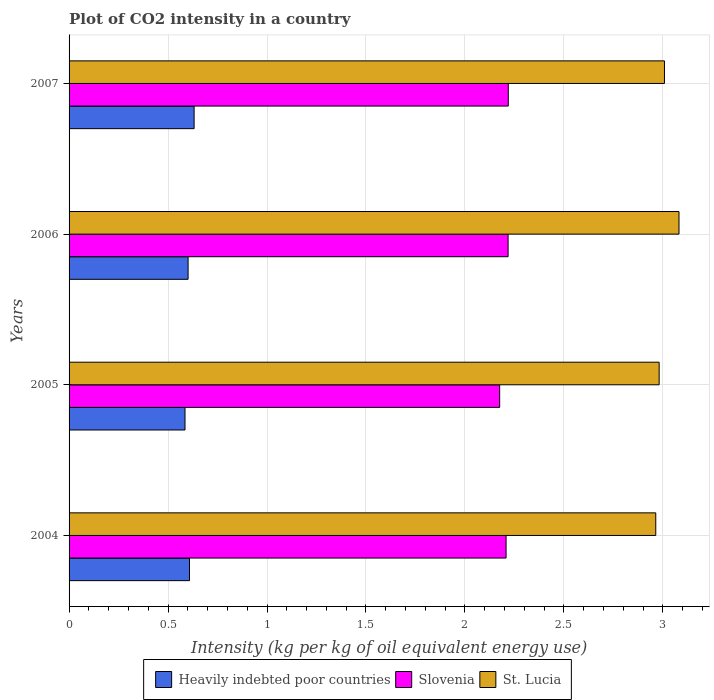Are the number of bars per tick equal to the number of legend labels?
Offer a very short reply. Yes. Are the number of bars on each tick of the Y-axis equal?
Give a very brief answer. Yes. How many bars are there on the 3rd tick from the top?
Your answer should be compact. 3. How many bars are there on the 4th tick from the bottom?
Your answer should be compact. 3. What is the label of the 3rd group of bars from the top?
Offer a very short reply. 2005. In how many cases, is the number of bars for a given year not equal to the number of legend labels?
Provide a short and direct response. 0. What is the CO2 intensity in in Heavily indebted poor countries in 2004?
Provide a short and direct response. 0.61. Across all years, what is the maximum CO2 intensity in in Slovenia?
Your answer should be very brief. 2.22. Across all years, what is the minimum CO2 intensity in in Slovenia?
Provide a short and direct response. 2.18. In which year was the CO2 intensity in in St. Lucia minimum?
Your answer should be very brief. 2004. What is the total CO2 intensity in in Heavily indebted poor countries in the graph?
Offer a very short reply. 2.43. What is the difference between the CO2 intensity in in Slovenia in 2006 and that in 2007?
Offer a very short reply. -0. What is the difference between the CO2 intensity in in Slovenia in 2006 and the CO2 intensity in in Heavily indebted poor countries in 2005?
Provide a short and direct response. 1.63. What is the average CO2 intensity in in St. Lucia per year?
Provide a short and direct response. 3.01. In the year 2004, what is the difference between the CO2 intensity in in Heavily indebted poor countries and CO2 intensity in in Slovenia?
Give a very brief answer. -1.6. In how many years, is the CO2 intensity in in St. Lucia greater than 1.8 kg?
Ensure brevity in your answer.  4. What is the ratio of the CO2 intensity in in Slovenia in 2004 to that in 2006?
Give a very brief answer. 1. Is the difference between the CO2 intensity in in Heavily indebted poor countries in 2005 and 2007 greater than the difference between the CO2 intensity in in Slovenia in 2005 and 2007?
Offer a terse response. No. What is the difference between the highest and the second highest CO2 intensity in in Heavily indebted poor countries?
Provide a succinct answer. 0.02. What is the difference between the highest and the lowest CO2 intensity in in St. Lucia?
Make the answer very short. 0.12. Is the sum of the CO2 intensity in in Slovenia in 2005 and 2007 greater than the maximum CO2 intensity in in Heavily indebted poor countries across all years?
Your answer should be very brief. Yes. What does the 2nd bar from the top in 2005 represents?
Provide a short and direct response. Slovenia. What does the 2nd bar from the bottom in 2006 represents?
Make the answer very short. Slovenia. How many bars are there?
Provide a short and direct response. 12. Are all the bars in the graph horizontal?
Your answer should be very brief. Yes. How many years are there in the graph?
Offer a very short reply. 4. What is the difference between two consecutive major ticks on the X-axis?
Your response must be concise. 0.5. Does the graph contain grids?
Offer a terse response. Yes. How many legend labels are there?
Make the answer very short. 3. How are the legend labels stacked?
Your answer should be very brief. Horizontal. What is the title of the graph?
Offer a terse response. Plot of CO2 intensity in a country. Does "Mozambique" appear as one of the legend labels in the graph?
Make the answer very short. No. What is the label or title of the X-axis?
Ensure brevity in your answer.  Intensity (kg per kg of oil equivalent energy use). What is the label or title of the Y-axis?
Provide a succinct answer. Years. What is the Intensity (kg per kg of oil equivalent energy use) in Heavily indebted poor countries in 2004?
Your answer should be compact. 0.61. What is the Intensity (kg per kg of oil equivalent energy use) of Slovenia in 2004?
Make the answer very short. 2.21. What is the Intensity (kg per kg of oil equivalent energy use) of St. Lucia in 2004?
Give a very brief answer. 2.96. What is the Intensity (kg per kg of oil equivalent energy use) of Heavily indebted poor countries in 2005?
Your answer should be compact. 0.59. What is the Intensity (kg per kg of oil equivalent energy use) of Slovenia in 2005?
Your answer should be compact. 2.18. What is the Intensity (kg per kg of oil equivalent energy use) of St. Lucia in 2005?
Give a very brief answer. 2.98. What is the Intensity (kg per kg of oil equivalent energy use) of Heavily indebted poor countries in 2006?
Provide a short and direct response. 0.6. What is the Intensity (kg per kg of oil equivalent energy use) of Slovenia in 2006?
Offer a terse response. 2.22. What is the Intensity (kg per kg of oil equivalent energy use) in St. Lucia in 2006?
Your answer should be very brief. 3.08. What is the Intensity (kg per kg of oil equivalent energy use) in Heavily indebted poor countries in 2007?
Your answer should be compact. 0.63. What is the Intensity (kg per kg of oil equivalent energy use) in Slovenia in 2007?
Provide a short and direct response. 2.22. What is the Intensity (kg per kg of oil equivalent energy use) in St. Lucia in 2007?
Give a very brief answer. 3.01. Across all years, what is the maximum Intensity (kg per kg of oil equivalent energy use) of Heavily indebted poor countries?
Ensure brevity in your answer.  0.63. Across all years, what is the maximum Intensity (kg per kg of oil equivalent energy use) in Slovenia?
Keep it short and to the point. 2.22. Across all years, what is the maximum Intensity (kg per kg of oil equivalent energy use) in St. Lucia?
Offer a terse response. 3.08. Across all years, what is the minimum Intensity (kg per kg of oil equivalent energy use) in Heavily indebted poor countries?
Your response must be concise. 0.59. Across all years, what is the minimum Intensity (kg per kg of oil equivalent energy use) in Slovenia?
Make the answer very short. 2.18. Across all years, what is the minimum Intensity (kg per kg of oil equivalent energy use) in St. Lucia?
Ensure brevity in your answer.  2.96. What is the total Intensity (kg per kg of oil equivalent energy use) in Heavily indebted poor countries in the graph?
Keep it short and to the point. 2.43. What is the total Intensity (kg per kg of oil equivalent energy use) of Slovenia in the graph?
Your response must be concise. 8.82. What is the total Intensity (kg per kg of oil equivalent energy use) in St. Lucia in the graph?
Your answer should be very brief. 12.04. What is the difference between the Intensity (kg per kg of oil equivalent energy use) of Heavily indebted poor countries in 2004 and that in 2005?
Ensure brevity in your answer.  0.02. What is the difference between the Intensity (kg per kg of oil equivalent energy use) in Slovenia in 2004 and that in 2005?
Offer a terse response. 0.03. What is the difference between the Intensity (kg per kg of oil equivalent energy use) of St. Lucia in 2004 and that in 2005?
Provide a succinct answer. -0.02. What is the difference between the Intensity (kg per kg of oil equivalent energy use) in Heavily indebted poor countries in 2004 and that in 2006?
Offer a very short reply. 0.01. What is the difference between the Intensity (kg per kg of oil equivalent energy use) of Slovenia in 2004 and that in 2006?
Your answer should be compact. -0.01. What is the difference between the Intensity (kg per kg of oil equivalent energy use) of St. Lucia in 2004 and that in 2006?
Offer a very short reply. -0.12. What is the difference between the Intensity (kg per kg of oil equivalent energy use) of Heavily indebted poor countries in 2004 and that in 2007?
Your answer should be very brief. -0.02. What is the difference between the Intensity (kg per kg of oil equivalent energy use) in Slovenia in 2004 and that in 2007?
Your answer should be compact. -0.01. What is the difference between the Intensity (kg per kg of oil equivalent energy use) of St. Lucia in 2004 and that in 2007?
Provide a succinct answer. -0.04. What is the difference between the Intensity (kg per kg of oil equivalent energy use) in Heavily indebted poor countries in 2005 and that in 2006?
Provide a succinct answer. -0.02. What is the difference between the Intensity (kg per kg of oil equivalent energy use) in Slovenia in 2005 and that in 2006?
Your answer should be compact. -0.04. What is the difference between the Intensity (kg per kg of oil equivalent energy use) in St. Lucia in 2005 and that in 2006?
Provide a short and direct response. -0.1. What is the difference between the Intensity (kg per kg of oil equivalent energy use) in Heavily indebted poor countries in 2005 and that in 2007?
Your answer should be very brief. -0.05. What is the difference between the Intensity (kg per kg of oil equivalent energy use) in Slovenia in 2005 and that in 2007?
Ensure brevity in your answer.  -0.04. What is the difference between the Intensity (kg per kg of oil equivalent energy use) of St. Lucia in 2005 and that in 2007?
Provide a succinct answer. -0.03. What is the difference between the Intensity (kg per kg of oil equivalent energy use) of Heavily indebted poor countries in 2006 and that in 2007?
Offer a terse response. -0.03. What is the difference between the Intensity (kg per kg of oil equivalent energy use) of Slovenia in 2006 and that in 2007?
Your response must be concise. -0. What is the difference between the Intensity (kg per kg of oil equivalent energy use) of St. Lucia in 2006 and that in 2007?
Offer a terse response. 0.07. What is the difference between the Intensity (kg per kg of oil equivalent energy use) of Heavily indebted poor countries in 2004 and the Intensity (kg per kg of oil equivalent energy use) of Slovenia in 2005?
Make the answer very short. -1.57. What is the difference between the Intensity (kg per kg of oil equivalent energy use) of Heavily indebted poor countries in 2004 and the Intensity (kg per kg of oil equivalent energy use) of St. Lucia in 2005?
Provide a succinct answer. -2.37. What is the difference between the Intensity (kg per kg of oil equivalent energy use) of Slovenia in 2004 and the Intensity (kg per kg of oil equivalent energy use) of St. Lucia in 2005?
Your answer should be very brief. -0.77. What is the difference between the Intensity (kg per kg of oil equivalent energy use) in Heavily indebted poor countries in 2004 and the Intensity (kg per kg of oil equivalent energy use) in Slovenia in 2006?
Make the answer very short. -1.61. What is the difference between the Intensity (kg per kg of oil equivalent energy use) of Heavily indebted poor countries in 2004 and the Intensity (kg per kg of oil equivalent energy use) of St. Lucia in 2006?
Ensure brevity in your answer.  -2.47. What is the difference between the Intensity (kg per kg of oil equivalent energy use) in Slovenia in 2004 and the Intensity (kg per kg of oil equivalent energy use) in St. Lucia in 2006?
Offer a terse response. -0.87. What is the difference between the Intensity (kg per kg of oil equivalent energy use) of Heavily indebted poor countries in 2004 and the Intensity (kg per kg of oil equivalent energy use) of Slovenia in 2007?
Your answer should be compact. -1.61. What is the difference between the Intensity (kg per kg of oil equivalent energy use) in Heavily indebted poor countries in 2004 and the Intensity (kg per kg of oil equivalent energy use) in St. Lucia in 2007?
Offer a very short reply. -2.4. What is the difference between the Intensity (kg per kg of oil equivalent energy use) of Slovenia in 2004 and the Intensity (kg per kg of oil equivalent energy use) of St. Lucia in 2007?
Your answer should be compact. -0.8. What is the difference between the Intensity (kg per kg of oil equivalent energy use) in Heavily indebted poor countries in 2005 and the Intensity (kg per kg of oil equivalent energy use) in Slovenia in 2006?
Ensure brevity in your answer.  -1.63. What is the difference between the Intensity (kg per kg of oil equivalent energy use) in Heavily indebted poor countries in 2005 and the Intensity (kg per kg of oil equivalent energy use) in St. Lucia in 2006?
Offer a very short reply. -2.5. What is the difference between the Intensity (kg per kg of oil equivalent energy use) in Slovenia in 2005 and the Intensity (kg per kg of oil equivalent energy use) in St. Lucia in 2006?
Give a very brief answer. -0.91. What is the difference between the Intensity (kg per kg of oil equivalent energy use) in Heavily indebted poor countries in 2005 and the Intensity (kg per kg of oil equivalent energy use) in Slovenia in 2007?
Your response must be concise. -1.63. What is the difference between the Intensity (kg per kg of oil equivalent energy use) of Heavily indebted poor countries in 2005 and the Intensity (kg per kg of oil equivalent energy use) of St. Lucia in 2007?
Provide a short and direct response. -2.42. What is the difference between the Intensity (kg per kg of oil equivalent energy use) in Slovenia in 2005 and the Intensity (kg per kg of oil equivalent energy use) in St. Lucia in 2007?
Keep it short and to the point. -0.83. What is the difference between the Intensity (kg per kg of oil equivalent energy use) in Heavily indebted poor countries in 2006 and the Intensity (kg per kg of oil equivalent energy use) in Slovenia in 2007?
Your response must be concise. -1.62. What is the difference between the Intensity (kg per kg of oil equivalent energy use) in Heavily indebted poor countries in 2006 and the Intensity (kg per kg of oil equivalent energy use) in St. Lucia in 2007?
Make the answer very short. -2.41. What is the difference between the Intensity (kg per kg of oil equivalent energy use) of Slovenia in 2006 and the Intensity (kg per kg of oil equivalent energy use) of St. Lucia in 2007?
Ensure brevity in your answer.  -0.79. What is the average Intensity (kg per kg of oil equivalent energy use) in Heavily indebted poor countries per year?
Your answer should be very brief. 0.61. What is the average Intensity (kg per kg of oil equivalent energy use) of Slovenia per year?
Your answer should be very brief. 2.21. What is the average Intensity (kg per kg of oil equivalent energy use) in St. Lucia per year?
Offer a terse response. 3.01. In the year 2004, what is the difference between the Intensity (kg per kg of oil equivalent energy use) in Heavily indebted poor countries and Intensity (kg per kg of oil equivalent energy use) in Slovenia?
Your answer should be very brief. -1.6. In the year 2004, what is the difference between the Intensity (kg per kg of oil equivalent energy use) in Heavily indebted poor countries and Intensity (kg per kg of oil equivalent energy use) in St. Lucia?
Your answer should be very brief. -2.36. In the year 2004, what is the difference between the Intensity (kg per kg of oil equivalent energy use) in Slovenia and Intensity (kg per kg of oil equivalent energy use) in St. Lucia?
Give a very brief answer. -0.76. In the year 2005, what is the difference between the Intensity (kg per kg of oil equivalent energy use) of Heavily indebted poor countries and Intensity (kg per kg of oil equivalent energy use) of Slovenia?
Keep it short and to the point. -1.59. In the year 2005, what is the difference between the Intensity (kg per kg of oil equivalent energy use) of Heavily indebted poor countries and Intensity (kg per kg of oil equivalent energy use) of St. Lucia?
Give a very brief answer. -2.4. In the year 2005, what is the difference between the Intensity (kg per kg of oil equivalent energy use) in Slovenia and Intensity (kg per kg of oil equivalent energy use) in St. Lucia?
Provide a short and direct response. -0.81. In the year 2006, what is the difference between the Intensity (kg per kg of oil equivalent energy use) in Heavily indebted poor countries and Intensity (kg per kg of oil equivalent energy use) in Slovenia?
Your answer should be compact. -1.62. In the year 2006, what is the difference between the Intensity (kg per kg of oil equivalent energy use) in Heavily indebted poor countries and Intensity (kg per kg of oil equivalent energy use) in St. Lucia?
Give a very brief answer. -2.48. In the year 2006, what is the difference between the Intensity (kg per kg of oil equivalent energy use) of Slovenia and Intensity (kg per kg of oil equivalent energy use) of St. Lucia?
Keep it short and to the point. -0.86. In the year 2007, what is the difference between the Intensity (kg per kg of oil equivalent energy use) in Heavily indebted poor countries and Intensity (kg per kg of oil equivalent energy use) in Slovenia?
Your answer should be very brief. -1.59. In the year 2007, what is the difference between the Intensity (kg per kg of oil equivalent energy use) in Heavily indebted poor countries and Intensity (kg per kg of oil equivalent energy use) in St. Lucia?
Keep it short and to the point. -2.38. In the year 2007, what is the difference between the Intensity (kg per kg of oil equivalent energy use) in Slovenia and Intensity (kg per kg of oil equivalent energy use) in St. Lucia?
Keep it short and to the point. -0.79. What is the ratio of the Intensity (kg per kg of oil equivalent energy use) of Heavily indebted poor countries in 2004 to that in 2005?
Your answer should be compact. 1.04. What is the ratio of the Intensity (kg per kg of oil equivalent energy use) in Slovenia in 2004 to that in 2005?
Your response must be concise. 1.01. What is the ratio of the Intensity (kg per kg of oil equivalent energy use) of Heavily indebted poor countries in 2004 to that in 2006?
Make the answer very short. 1.01. What is the ratio of the Intensity (kg per kg of oil equivalent energy use) in St. Lucia in 2004 to that in 2006?
Give a very brief answer. 0.96. What is the ratio of the Intensity (kg per kg of oil equivalent energy use) of Heavily indebted poor countries in 2004 to that in 2007?
Your answer should be compact. 0.96. What is the ratio of the Intensity (kg per kg of oil equivalent energy use) of St. Lucia in 2004 to that in 2007?
Make the answer very short. 0.99. What is the ratio of the Intensity (kg per kg of oil equivalent energy use) of Heavily indebted poor countries in 2005 to that in 2006?
Your answer should be very brief. 0.97. What is the ratio of the Intensity (kg per kg of oil equivalent energy use) in Slovenia in 2005 to that in 2006?
Provide a succinct answer. 0.98. What is the ratio of the Intensity (kg per kg of oil equivalent energy use) in St. Lucia in 2005 to that in 2006?
Your answer should be very brief. 0.97. What is the ratio of the Intensity (kg per kg of oil equivalent energy use) in Heavily indebted poor countries in 2005 to that in 2007?
Your response must be concise. 0.93. What is the ratio of the Intensity (kg per kg of oil equivalent energy use) in Slovenia in 2005 to that in 2007?
Provide a short and direct response. 0.98. What is the ratio of the Intensity (kg per kg of oil equivalent energy use) of Heavily indebted poor countries in 2006 to that in 2007?
Give a very brief answer. 0.95. What is the ratio of the Intensity (kg per kg of oil equivalent energy use) of Slovenia in 2006 to that in 2007?
Offer a very short reply. 1. What is the ratio of the Intensity (kg per kg of oil equivalent energy use) in St. Lucia in 2006 to that in 2007?
Provide a succinct answer. 1.02. What is the difference between the highest and the second highest Intensity (kg per kg of oil equivalent energy use) of Heavily indebted poor countries?
Your answer should be very brief. 0.02. What is the difference between the highest and the second highest Intensity (kg per kg of oil equivalent energy use) of Slovenia?
Offer a very short reply. 0. What is the difference between the highest and the second highest Intensity (kg per kg of oil equivalent energy use) in St. Lucia?
Keep it short and to the point. 0.07. What is the difference between the highest and the lowest Intensity (kg per kg of oil equivalent energy use) of Heavily indebted poor countries?
Offer a very short reply. 0.05. What is the difference between the highest and the lowest Intensity (kg per kg of oil equivalent energy use) in Slovenia?
Your answer should be compact. 0.04. What is the difference between the highest and the lowest Intensity (kg per kg of oil equivalent energy use) in St. Lucia?
Make the answer very short. 0.12. 